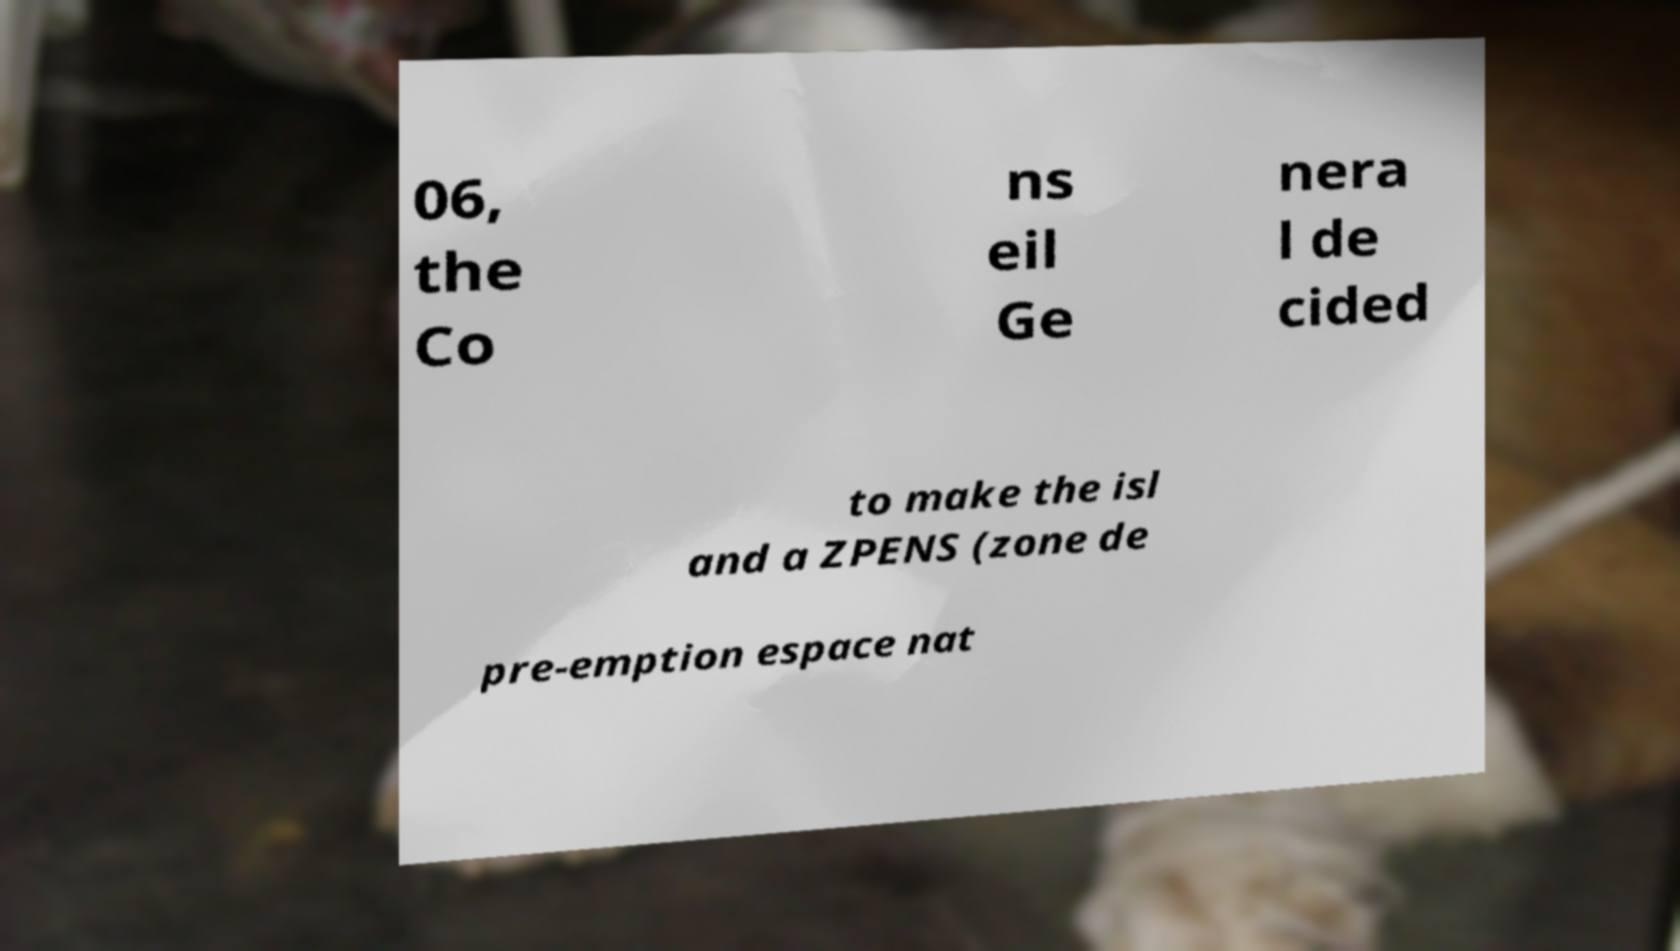Can you read and provide the text displayed in the image?This photo seems to have some interesting text. Can you extract and type it out for me? 06, the Co ns eil Ge nera l de cided to make the isl and a ZPENS (zone de pre-emption espace nat 